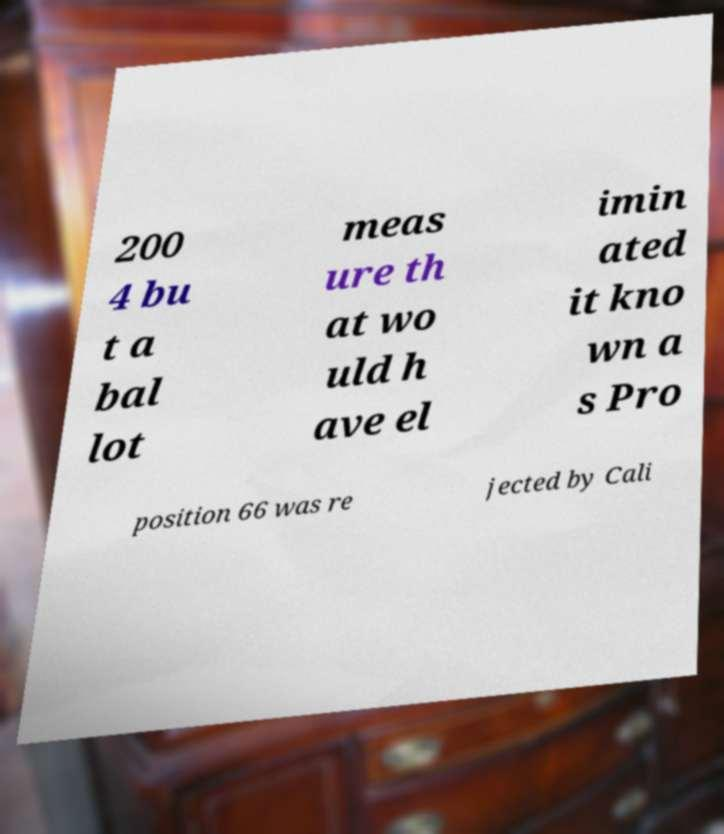Please identify and transcribe the text found in this image. 200 4 bu t a bal lot meas ure th at wo uld h ave el imin ated it kno wn a s Pro position 66 was re jected by Cali 